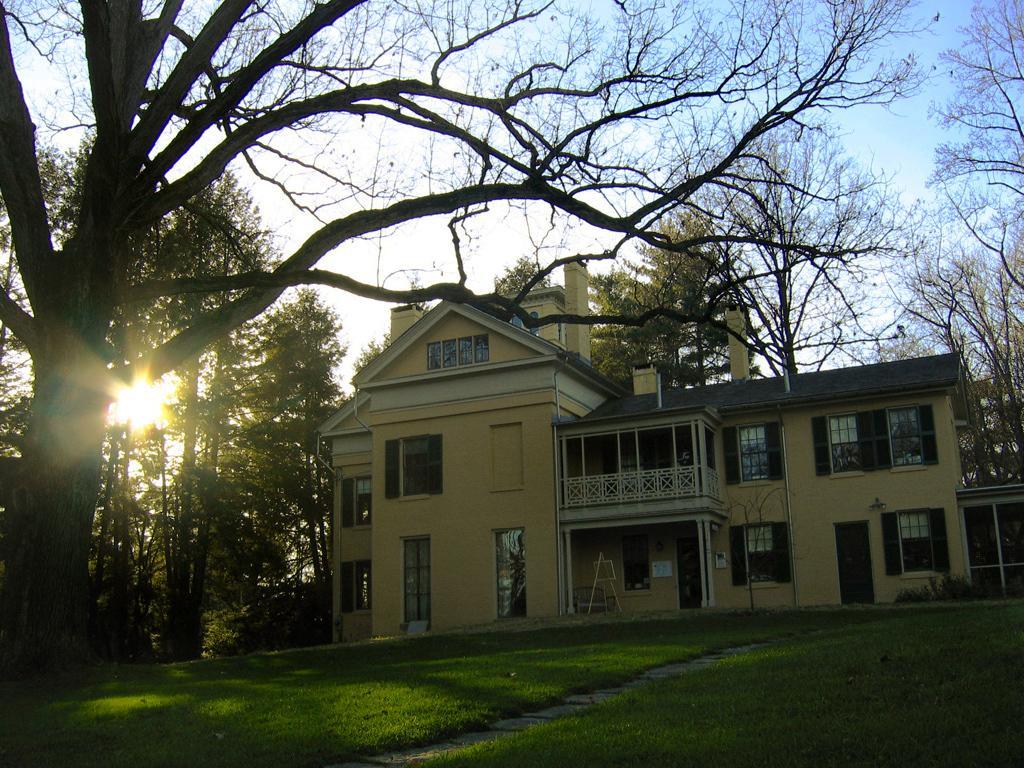Describe this image in one or two sentences. In this image I can see many trees and the building with railing and the windows. In the background I can see the sun and the sky. 